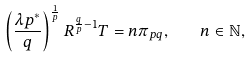<formula> <loc_0><loc_0><loc_500><loc_500>\left ( \frac { \lambda p ^ { * } } { q } \right ) ^ { \frac { 1 } { p } } R ^ { \frac { q } { p } - 1 } T = n \pi _ { p q } , \quad n \in \mathbb { N } ,</formula> 